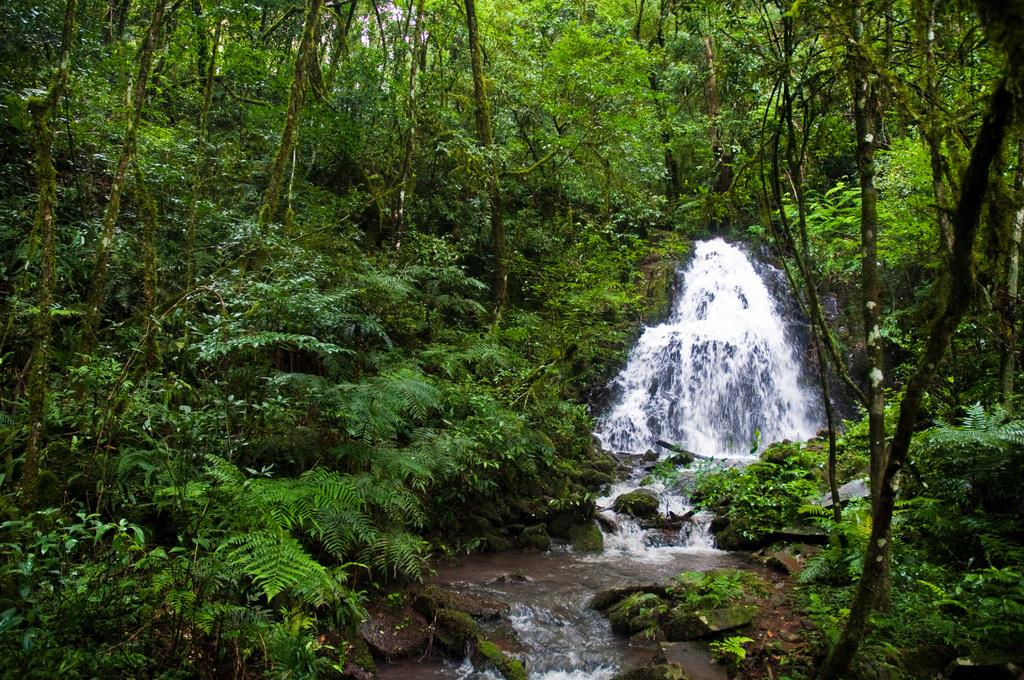What type of vegetation can be seen in the image? There are trees and plants in the image. What natural element is visible in the image? There is water visible in the image. How many people are in the crowd in the image? There is no crowd present in the image; it features trees, plants, and water. What season is depicted in the image? The image does not depict a specific season, as there are no seasonal indicators present. 